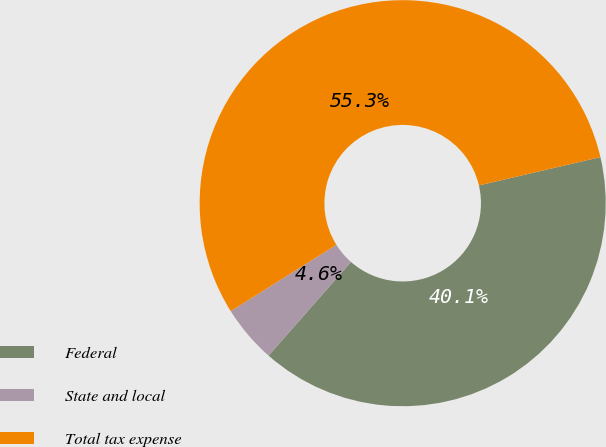<chart> <loc_0><loc_0><loc_500><loc_500><pie_chart><fcel>Federal<fcel>State and local<fcel>Total tax expense<nl><fcel>40.13%<fcel>4.59%<fcel>55.28%<nl></chart> 